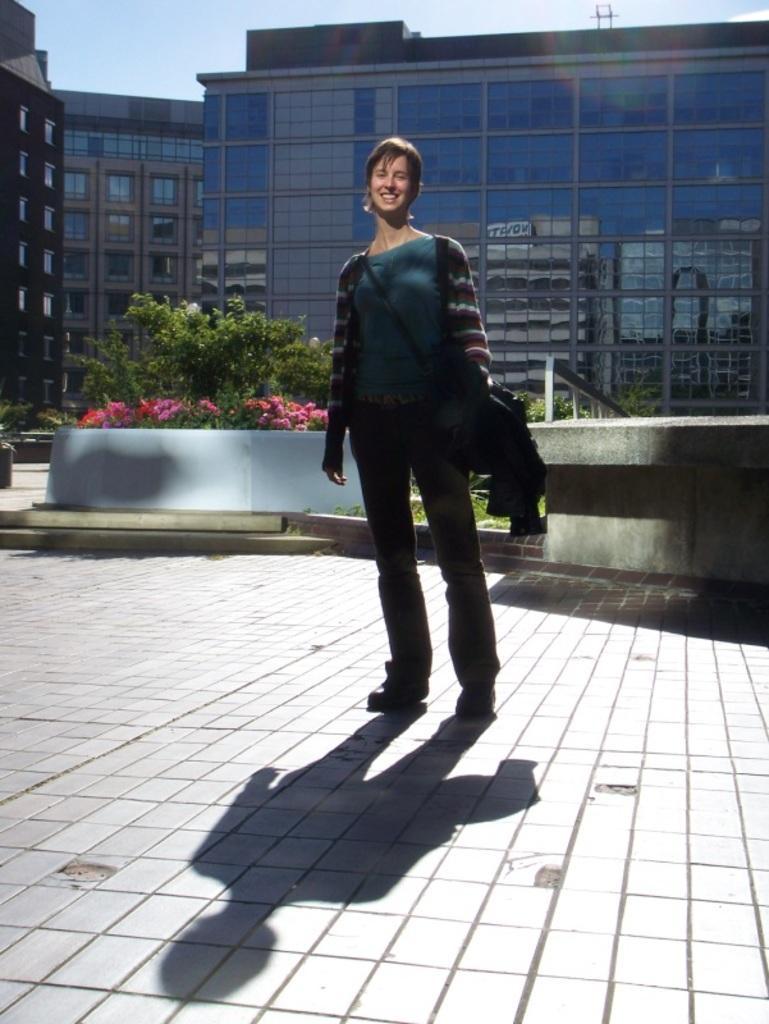Describe this image in one or two sentences. In the center of the image we can see a lady standing and smiling. In the background there are plants, flowers, buildings and sky. 